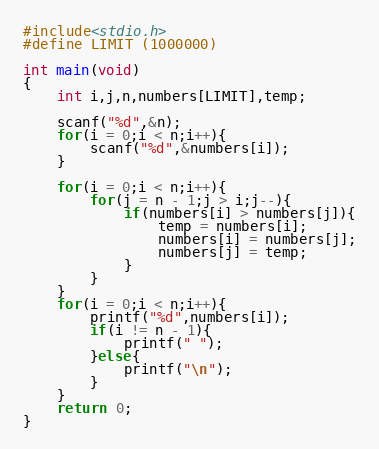<code> <loc_0><loc_0><loc_500><loc_500><_C_>#include<stdio.h>
#define LIMIT (1000000)

int main(void)
{
    int i,j,n,numbers[LIMIT],temp;

    scanf("%d",&n);
    for(i = 0;i < n;i++){
        scanf("%d",&numbers[i]);
    }

    for(i = 0;i < n;i++){
        for(j = n - 1;j > i;j--){
            if(numbers[i] > numbers[j]){
                temp = numbers[i];
                numbers[i] = numbers[j];
                numbers[j] = temp;
            }
        }
    }
    for(i = 0;i < n;i++){
        printf("%d",numbers[i]);
        if(i != n - 1){
            printf(" ");
        }else{
            printf("\n");
        }
    }
    return 0;
}</code> 